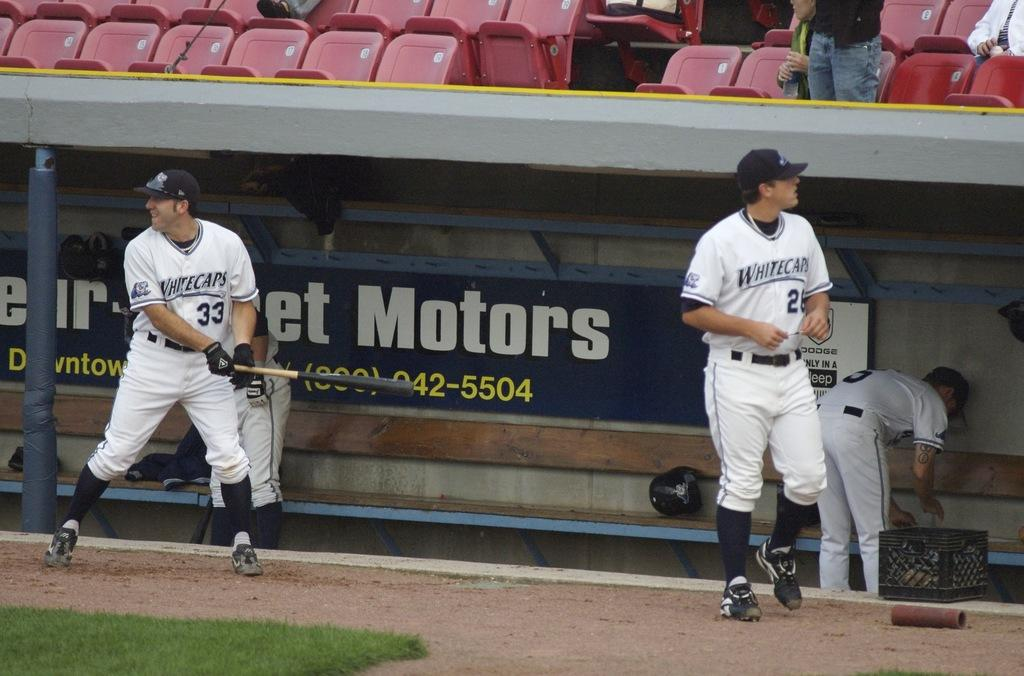<image>
Relay a brief, clear account of the picture shown. Several Whitecaps baseball players warm up in front of the dugout. 